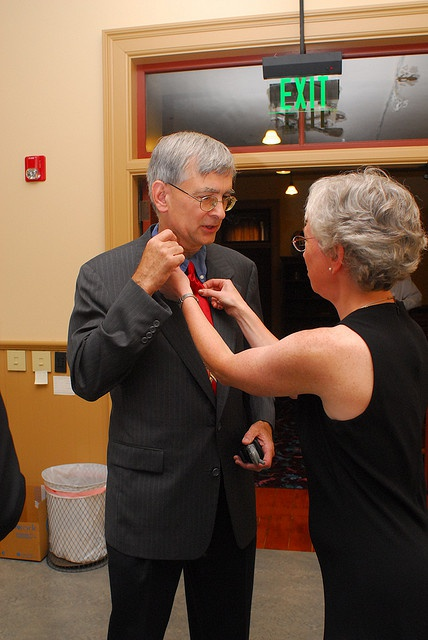Describe the objects in this image and their specific colors. I can see people in tan, black, brown, and maroon tones, people in tan, black, gray, and salmon tones, people in tan, black, maroon, and brown tones, tie in tan, red, maroon, and black tones, and cell phone in tan, black, gray, and maroon tones in this image. 